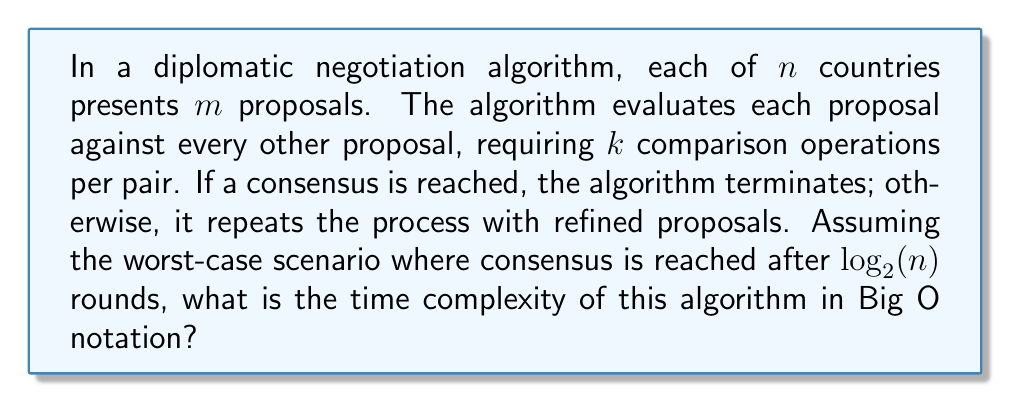Show me your answer to this math problem. Let's break this down step-by-step:

1) In each round:
   - There are $n$ countries, each presenting $m$ proposals
   - Total number of proposals: $n \cdot m$
   - Each proposal is compared with every other proposal
   - Number of comparisons: $\binom{n \cdot m}{2} = \frac{(n \cdot m)(n \cdot m - 1)}{2}$
   - Each comparison requires $k$ operations

2) Time complexity for one round:
   $$T_{round} = k \cdot \frac{(n \cdot m)(n \cdot m - 1)}{2} = O(k \cdot n^2 \cdot m^2)$$

3) The algorithm repeats for $log_2(n)$ rounds in the worst case

4) Total time complexity:
   $$T_{total} = log_2(n) \cdot O(k \cdot n^2 \cdot m^2) = O(k \cdot n^2 \cdot m^2 \cdot log_2(n))$$

5) Since $k$ and $m$ are constants, we can simplify:
   $$T_{total} = O(n^2 \cdot log_2(n))$$

This analysis assumes that the time for proposal refinement between rounds is negligible compared to the comparison operations.
Answer: $O(n^2 \cdot log_2(n))$ 